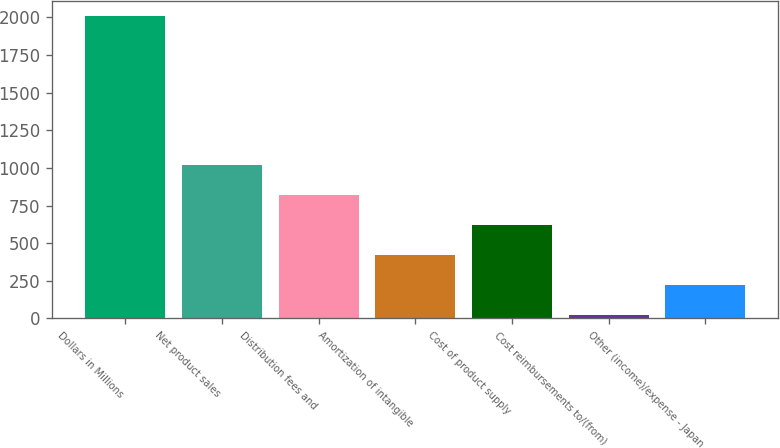Convert chart. <chart><loc_0><loc_0><loc_500><loc_500><bar_chart><fcel>Dollars in Millions<fcel>Net product sales<fcel>Distribution fees and<fcel>Amortization of intangible<fcel>Cost of product supply<fcel>Cost reimbursements to/(from)<fcel>Other (income)/expense - Japan<nl><fcel>2012<fcel>1017.5<fcel>818.6<fcel>420.8<fcel>619.7<fcel>23<fcel>221.9<nl></chart> 